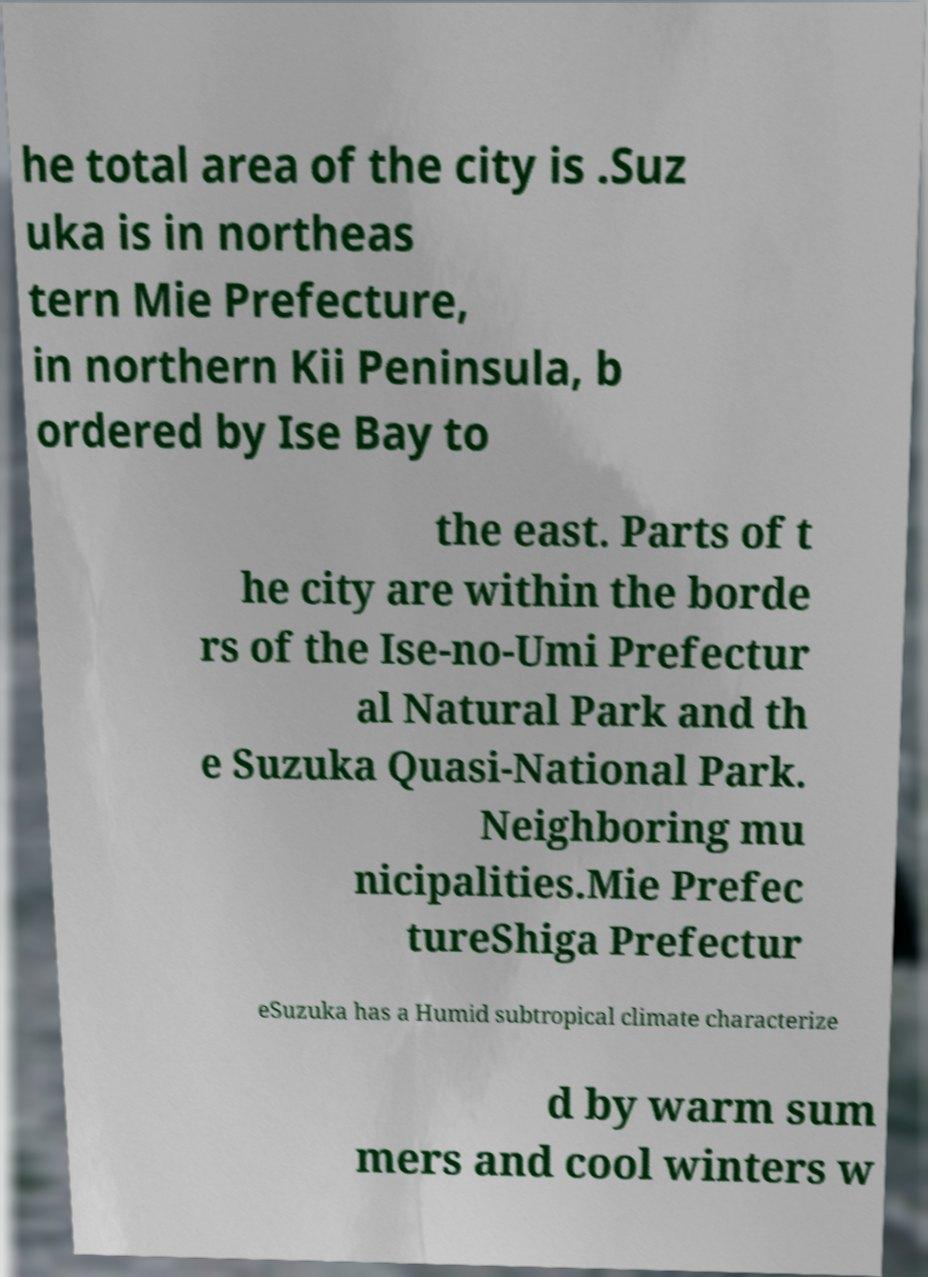For documentation purposes, I need the text within this image transcribed. Could you provide that? he total area of the city is .Suz uka is in northeas tern Mie Prefecture, in northern Kii Peninsula, b ordered by Ise Bay to the east. Parts of t he city are within the borde rs of the Ise-no-Umi Prefectur al Natural Park and th e Suzuka Quasi-National Park. Neighboring mu nicipalities.Mie Prefec tureShiga Prefectur eSuzuka has a Humid subtropical climate characterize d by warm sum mers and cool winters w 